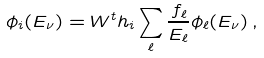<formula> <loc_0><loc_0><loc_500><loc_500>\phi _ { i } ( E _ { \nu } ) = W ^ { t } h _ { i } \sum _ { \ell } \frac { f _ { \ell } } { E _ { \ell } } \phi _ { \ell } ( E _ { \nu } ) \, ,</formula> 